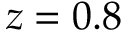<formula> <loc_0><loc_0><loc_500><loc_500>z = 0 . 8</formula> 